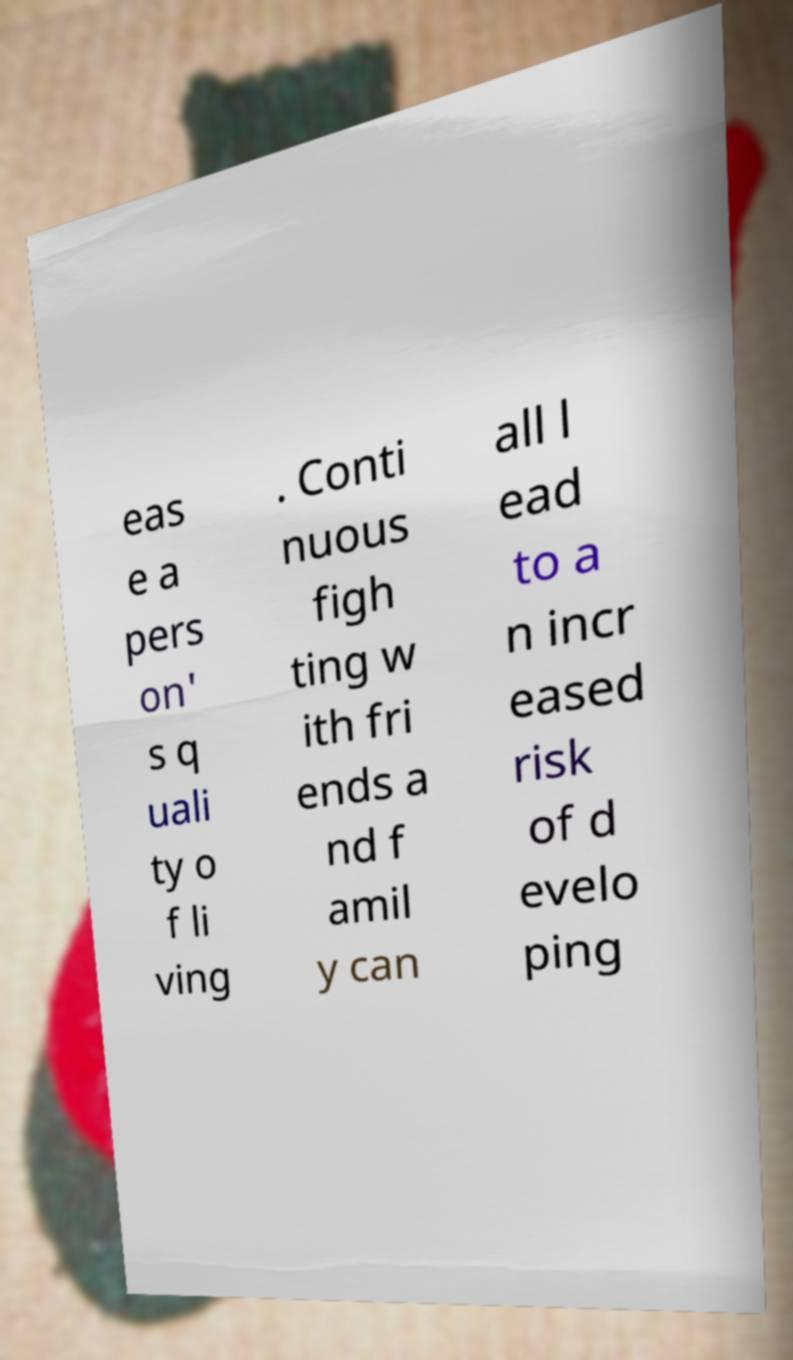I need the written content from this picture converted into text. Can you do that? eas e a pers on' s q uali ty o f li ving . Conti nuous figh ting w ith fri ends a nd f amil y can all l ead to a n incr eased risk of d evelo ping 